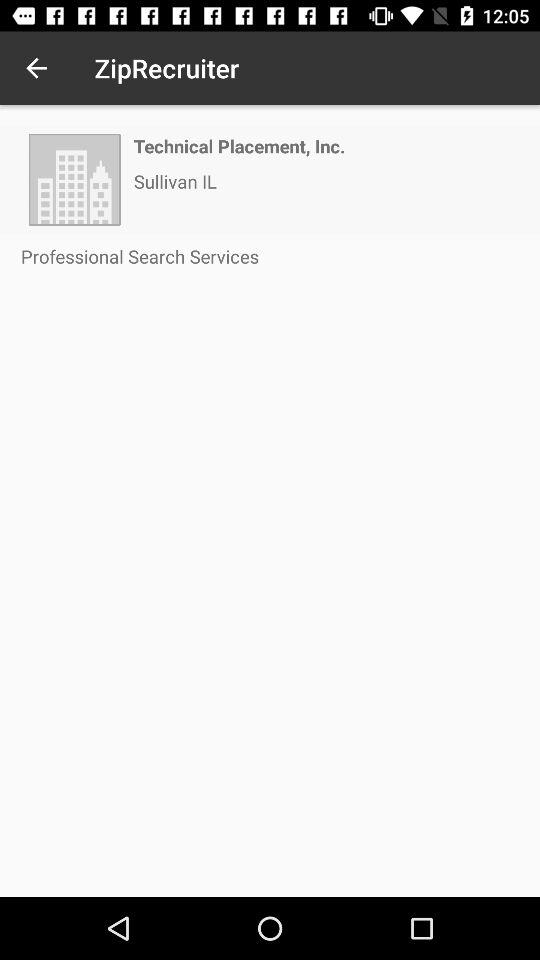What is the city name? The city name is Sullivan. 